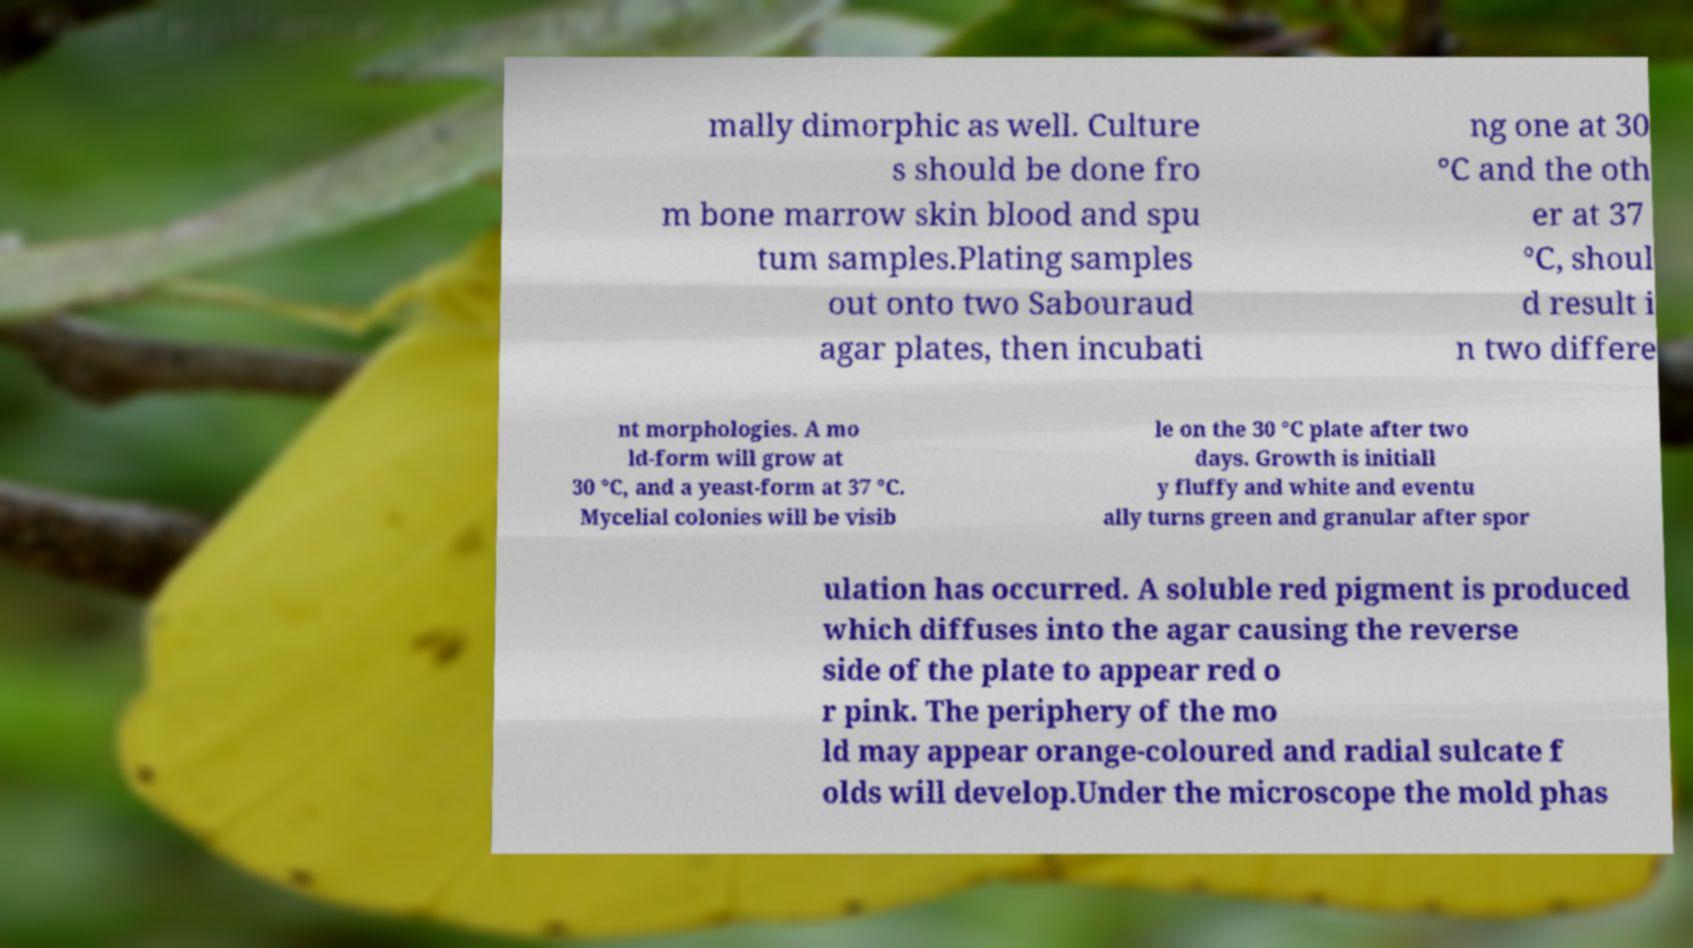I need the written content from this picture converted into text. Can you do that? mally dimorphic as well. Culture s should be done fro m bone marrow skin blood and spu tum samples.Plating samples out onto two Sabouraud agar plates, then incubati ng one at 30 °C and the oth er at 37 °C, shoul d result i n two differe nt morphologies. A mo ld-form will grow at 30 °C, and a yeast-form at 37 °C. Mycelial colonies will be visib le on the 30 °C plate after two days. Growth is initiall y fluffy and white and eventu ally turns green and granular after spor ulation has occurred. A soluble red pigment is produced which diffuses into the agar causing the reverse side of the plate to appear red o r pink. The periphery of the mo ld may appear orange-coloured and radial sulcate f olds will develop.Under the microscope the mold phas 